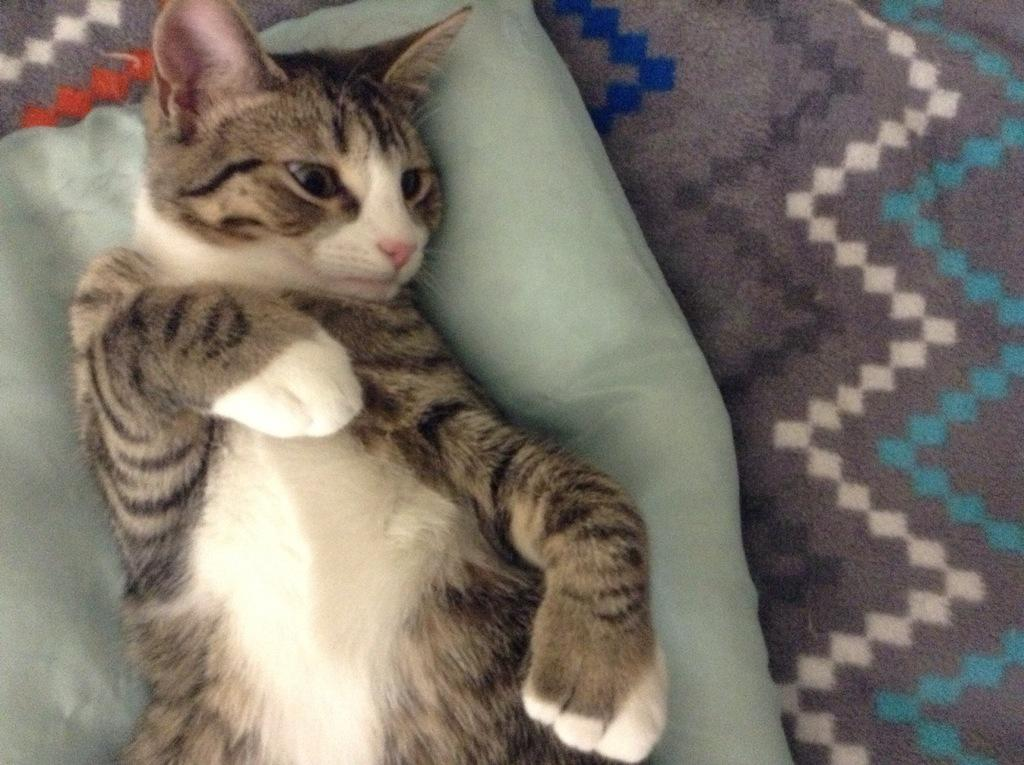What animal is present in the image? There is a cat in the image. Where is the cat located in the image? The cat is laying on a bed. What colors can be seen on the cat's fur? The cat has brown and white coloring. What type of judge is depicted in the image? There is no judge present in the image; it features a cat laying on a bed. What role does the slave play in the image? There is no slave present in the image; it features a cat laying on a bed. 